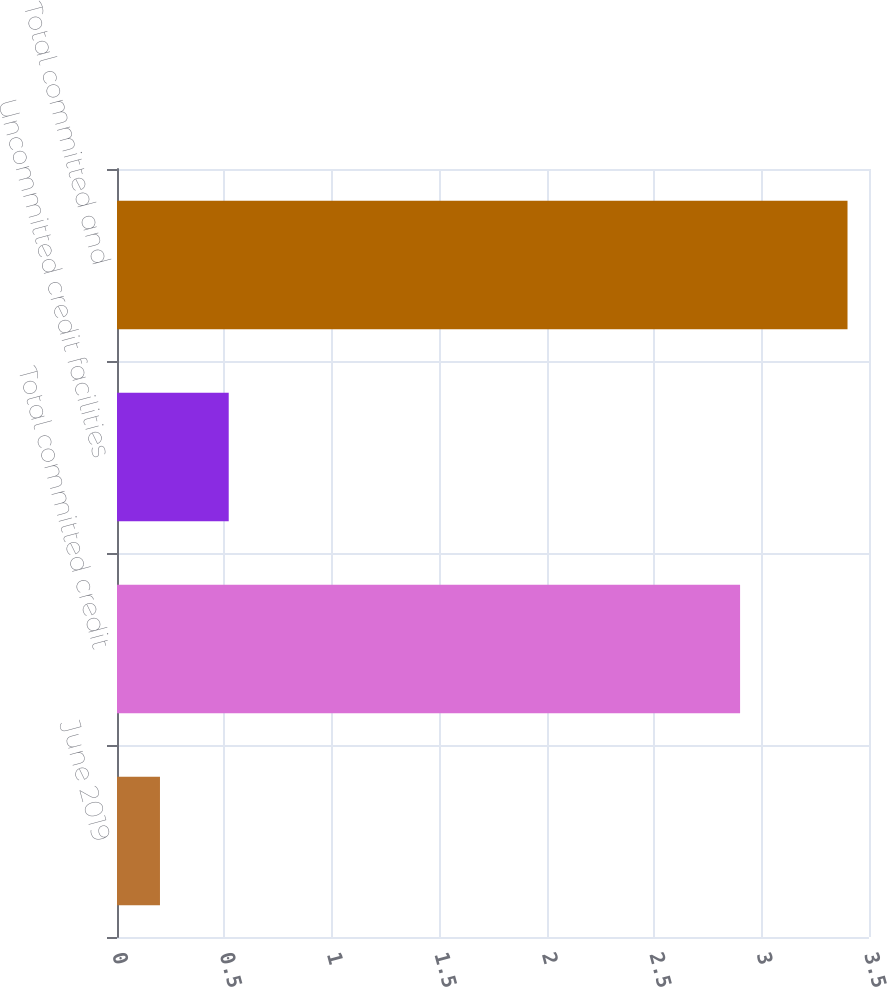Convert chart. <chart><loc_0><loc_0><loc_500><loc_500><bar_chart><fcel>June 2019<fcel>Total committed credit<fcel>Uncommitted credit facilities<fcel>Total committed and<nl><fcel>0.2<fcel>2.9<fcel>0.52<fcel>3.4<nl></chart> 